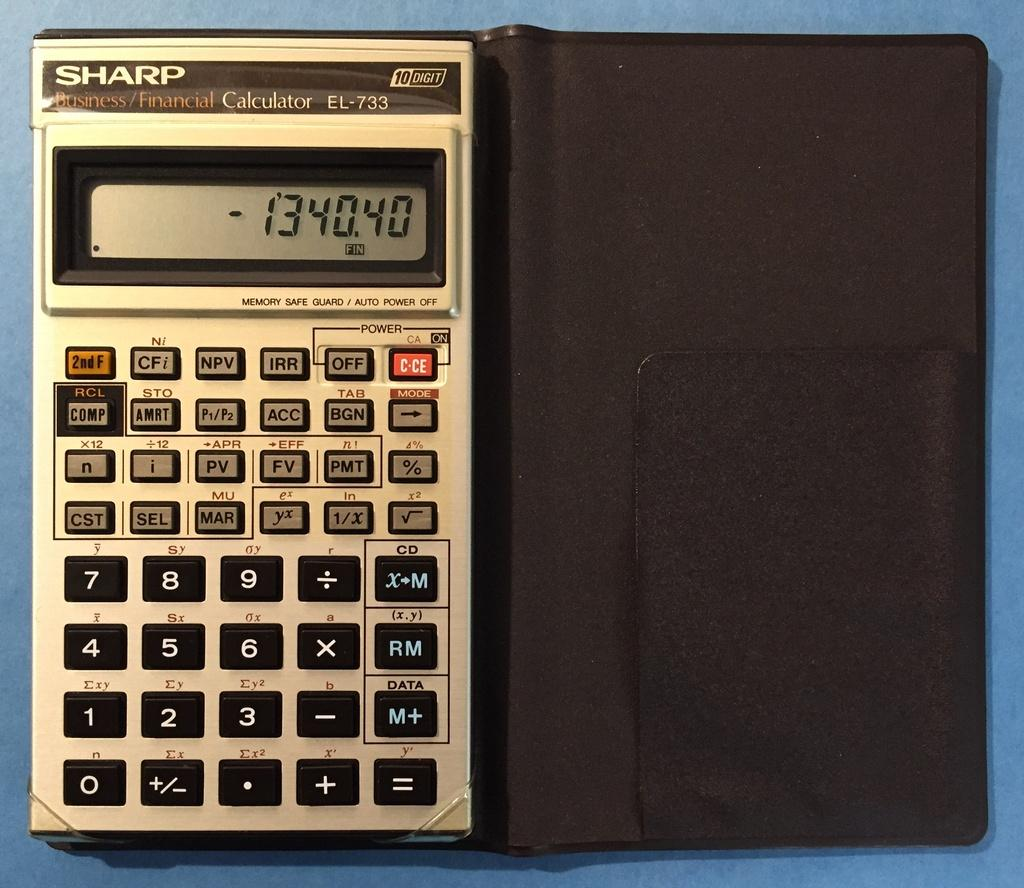<image>
Describe the image concisely. Old Sharp Calculator with the numbers "-1340.40" on the screen. 